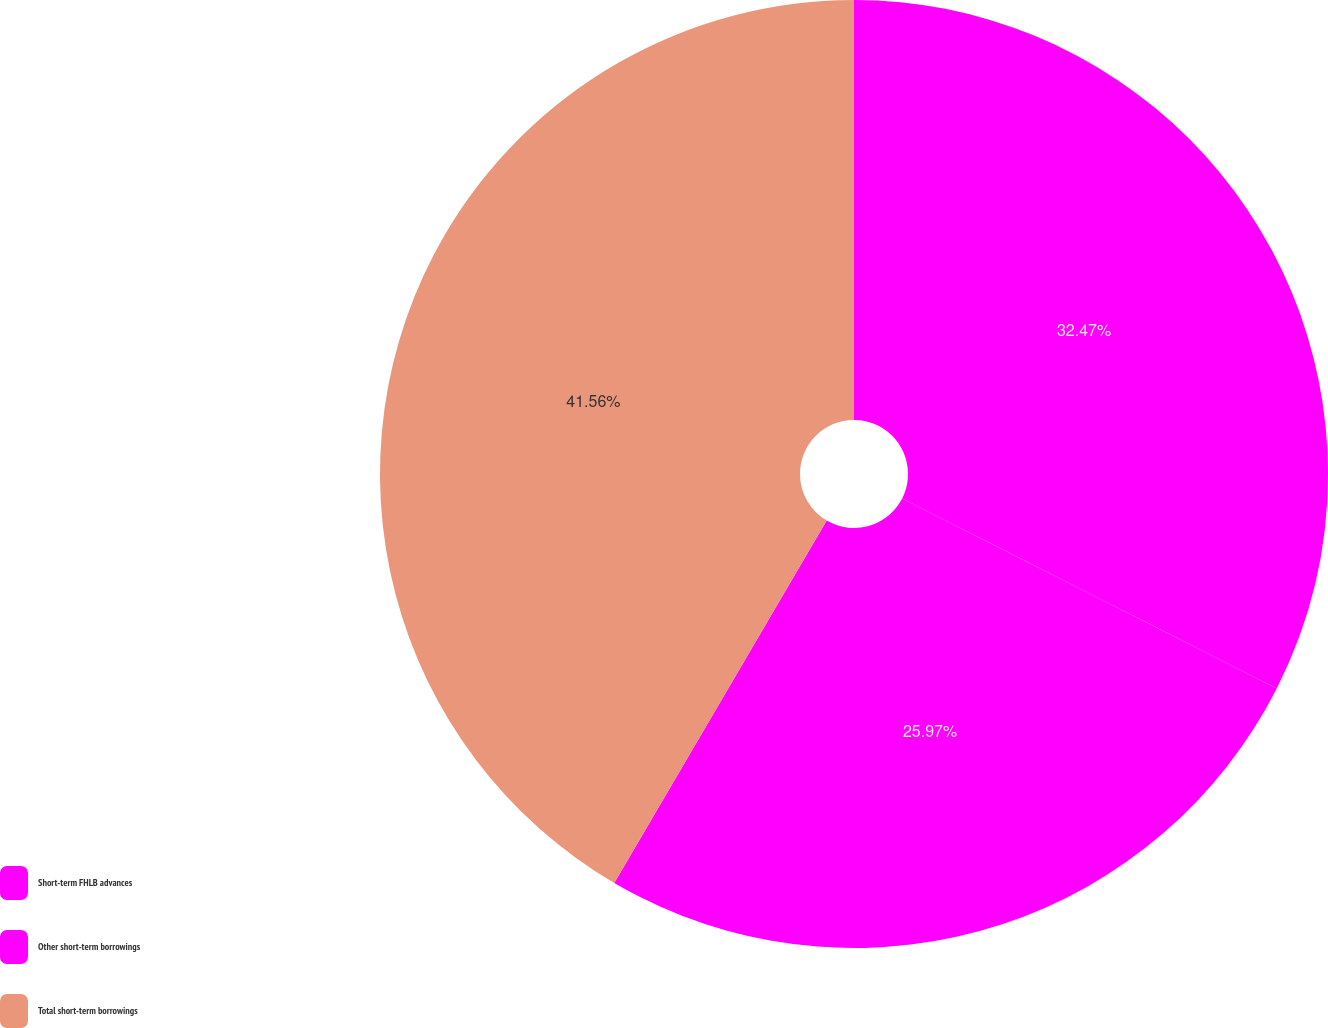Convert chart. <chart><loc_0><loc_0><loc_500><loc_500><pie_chart><fcel>Short-term FHLB advances<fcel>Other short-term borrowings<fcel>Total short-term borrowings<nl><fcel>32.47%<fcel>25.97%<fcel>41.56%<nl></chart> 